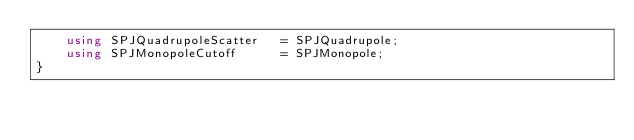Convert code to text. <code><loc_0><loc_0><loc_500><loc_500><_C++_>    using SPJQuadrupoleScatter   = SPJQuadrupole;
    using SPJMonopoleCutoff      = SPJMonopole;
}
</code> 